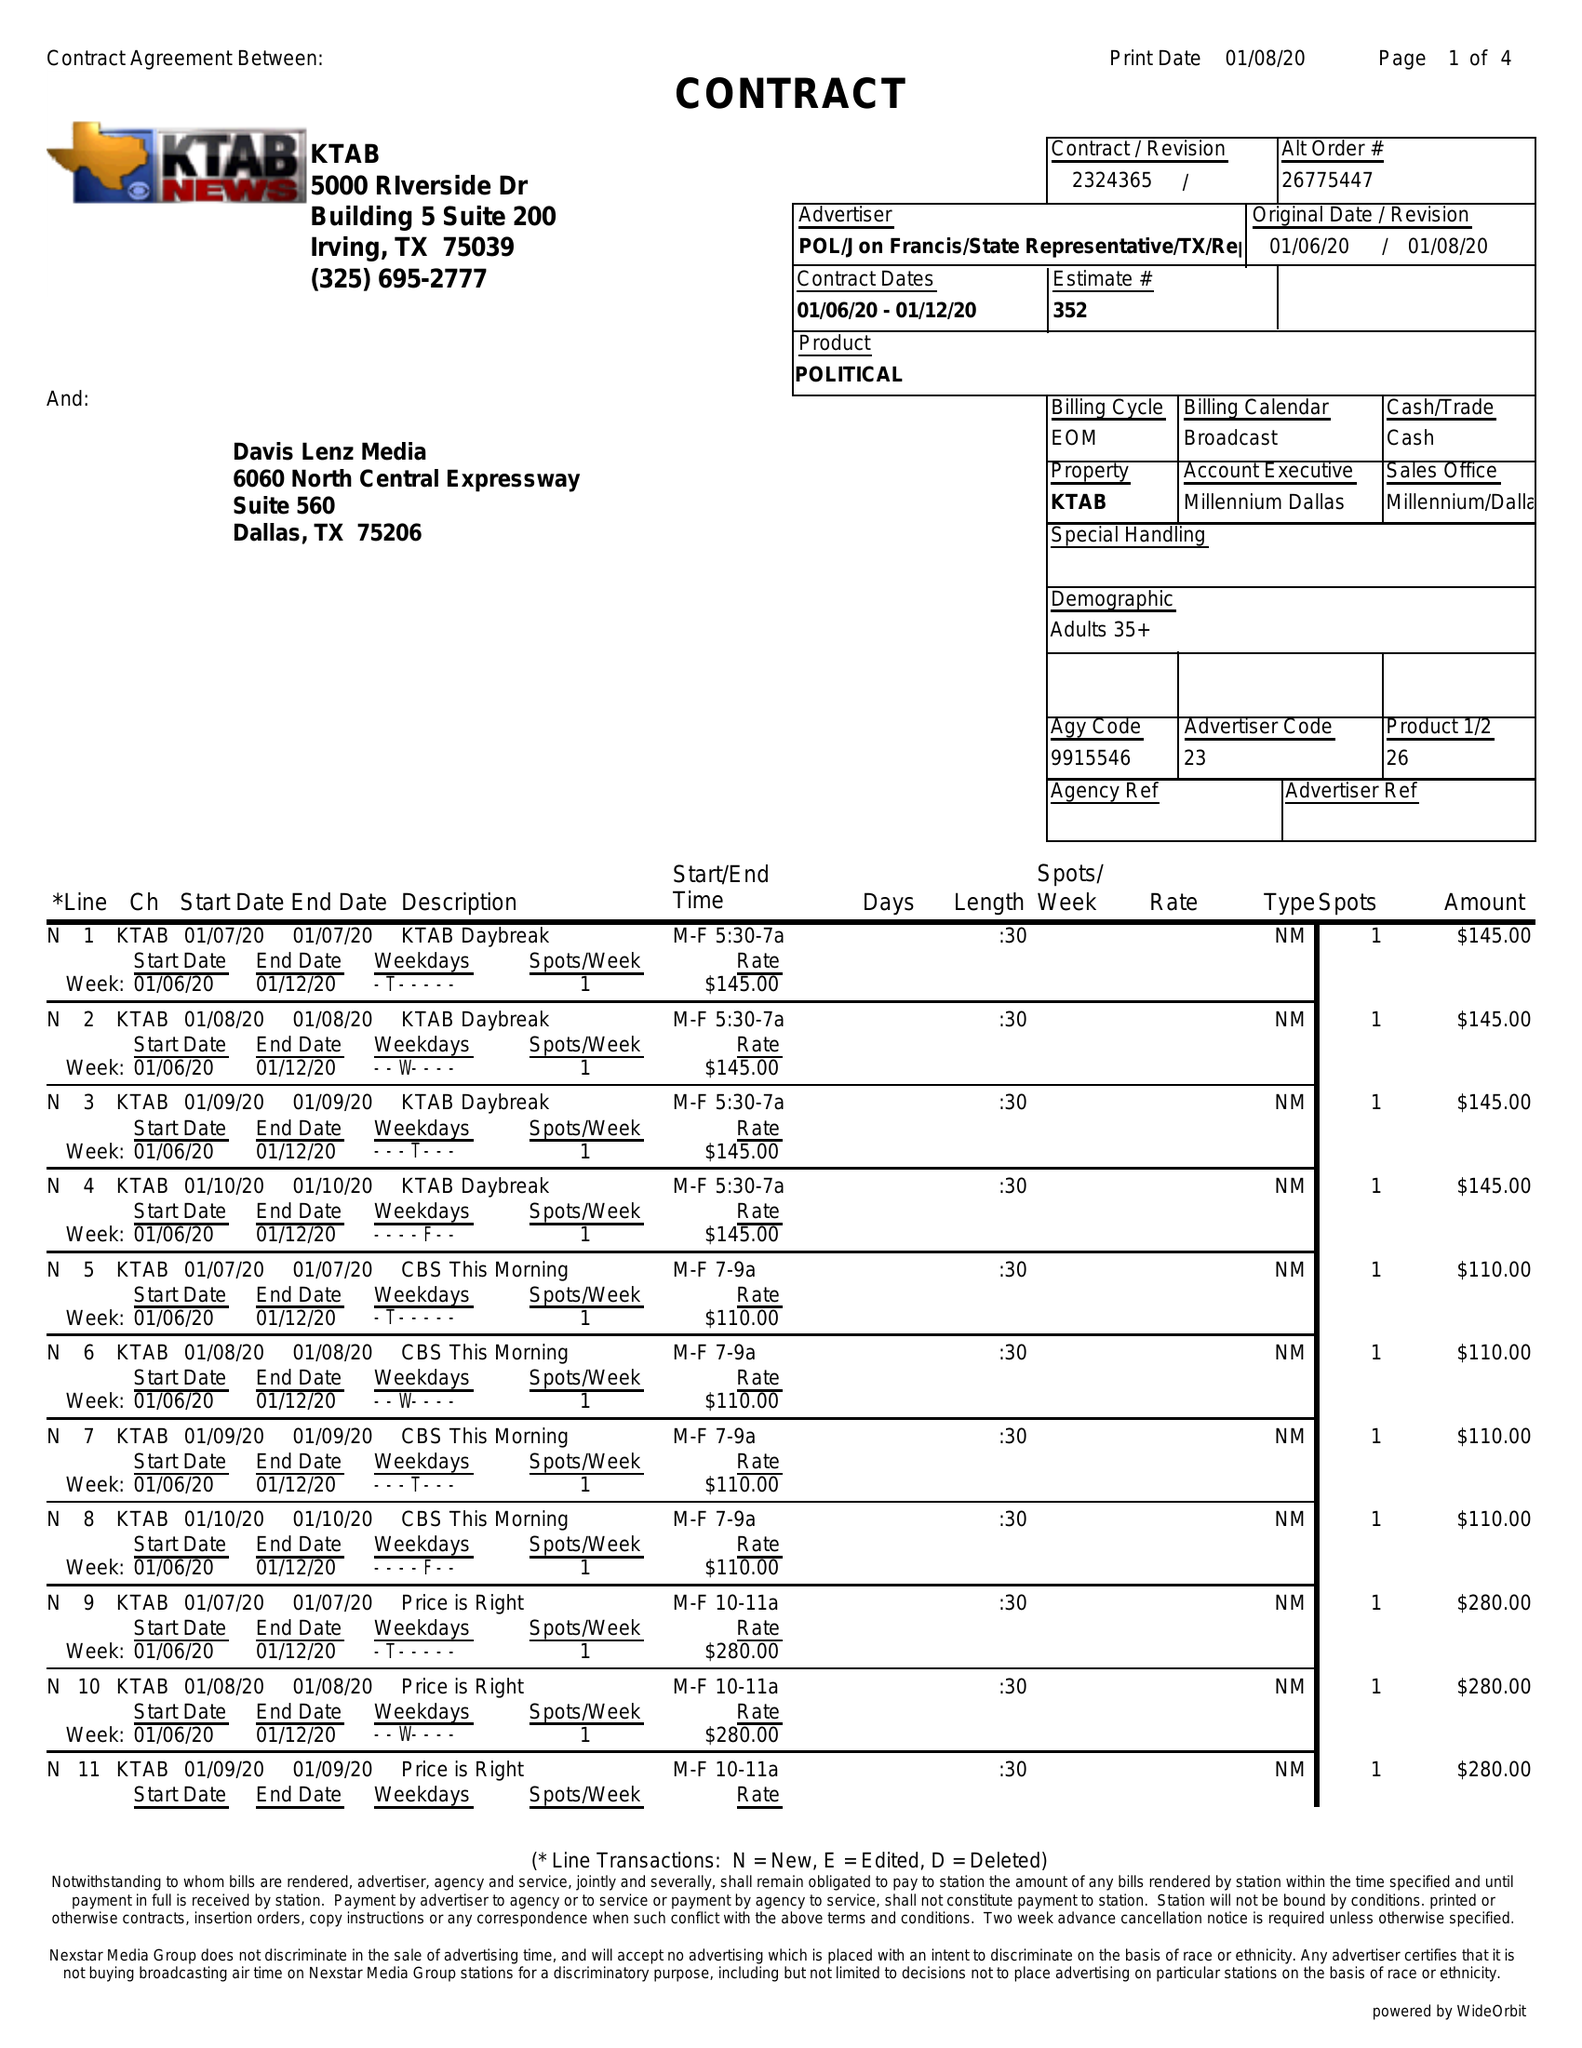What is the value for the flight_from?
Answer the question using a single word or phrase. 01/06/20 